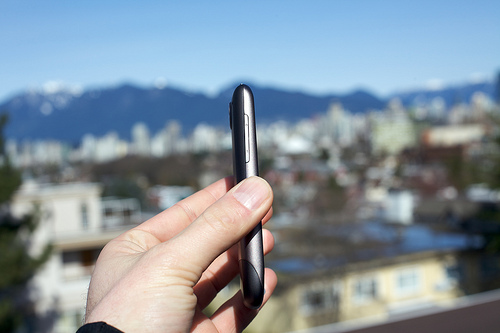<image>
Is the phone to the right of the mountains? No. The phone is not to the right of the mountains. The horizontal positioning shows a different relationship. 